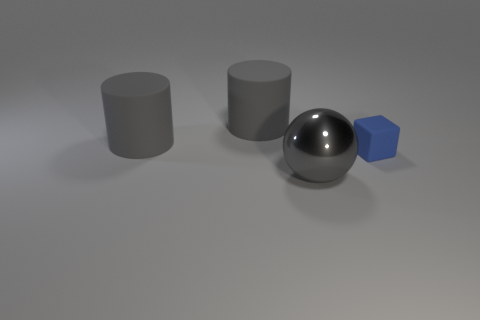Do the object right of the gray ball and the object in front of the tiny rubber cube have the same color?
Offer a terse response. No. Are there any other things that are the same material as the tiny cube?
Your answer should be very brief. Yes. There is a blue block; are there any blue cubes in front of it?
Offer a terse response. No. Is the number of big cylinders that are behind the blue cube the same as the number of gray metallic objects?
Keep it short and to the point. No. Are there any blue things that are behind the matte thing that is on the right side of the big object that is in front of the tiny cube?
Your answer should be compact. No. What is the blue thing made of?
Keep it short and to the point. Rubber. How many other objects are there of the same shape as the blue matte thing?
Provide a short and direct response. 0. Is the large gray shiny thing the same shape as the blue matte thing?
Your answer should be compact. No. How many objects are either big things that are on the left side of the large metallic thing or rubber things that are on the left side of the blue cube?
Your answer should be compact. 2. What number of things are large spheres or gray matte things?
Your answer should be very brief. 3. 